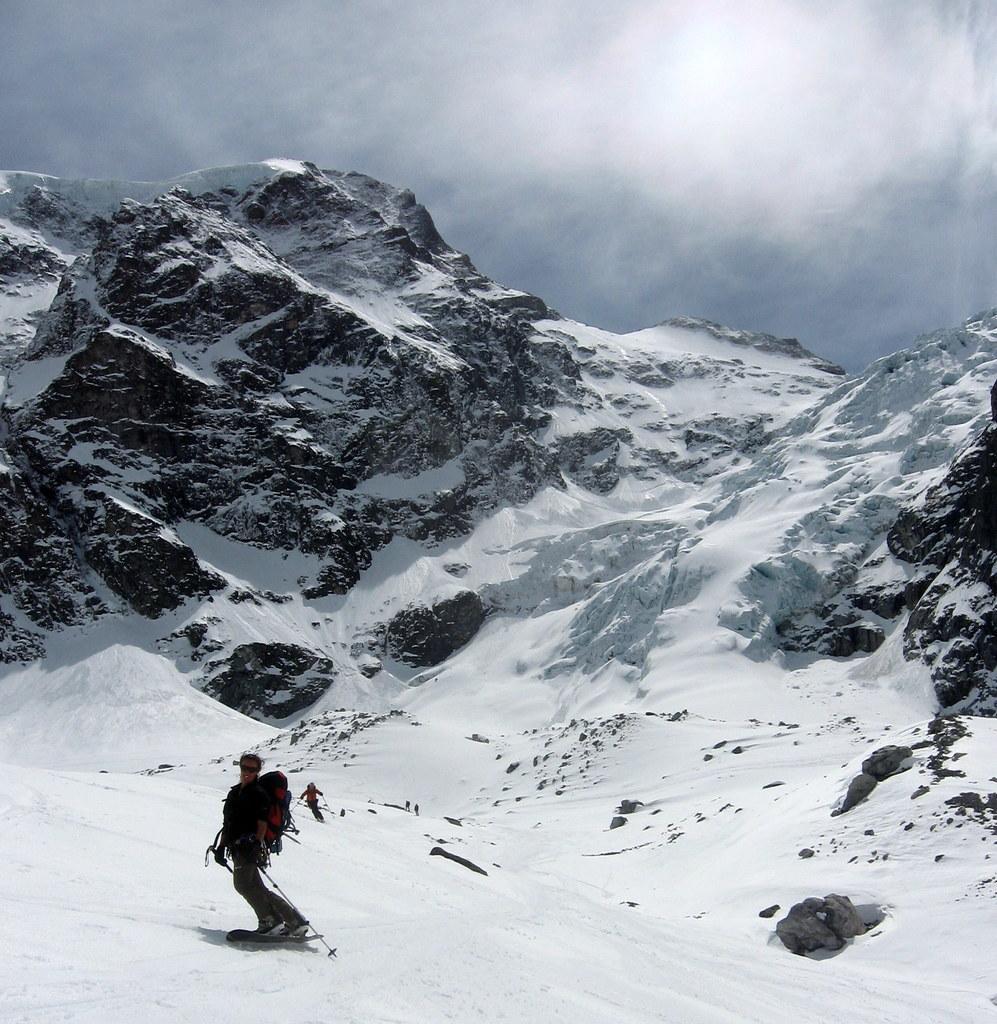Could you give a brief overview of what you see in this image? This image consists of ice. There are some persons in the middle, who are skiing on ice. There is sky at the top. 